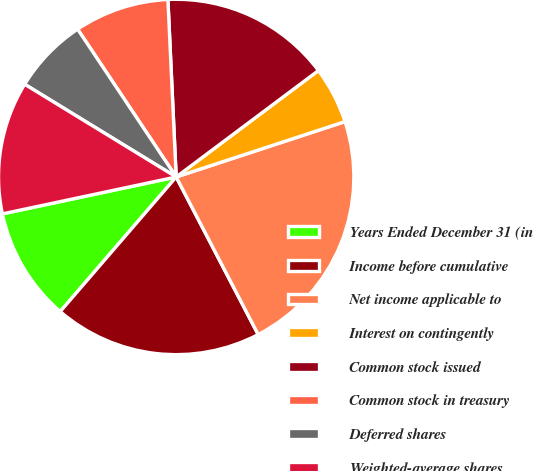Convert chart to OTSL. <chart><loc_0><loc_0><loc_500><loc_500><pie_chart><fcel>Years Ended December 31 (in<fcel>Income before cumulative<fcel>Net income applicable to<fcel>Interest on contingently<fcel>Common stock issued<fcel>Common stock in treasury<fcel>Deferred shares<fcel>Weighted-average shares<nl><fcel>10.35%<fcel>18.96%<fcel>22.41%<fcel>5.18%<fcel>15.52%<fcel>8.62%<fcel>6.9%<fcel>12.07%<nl></chart> 